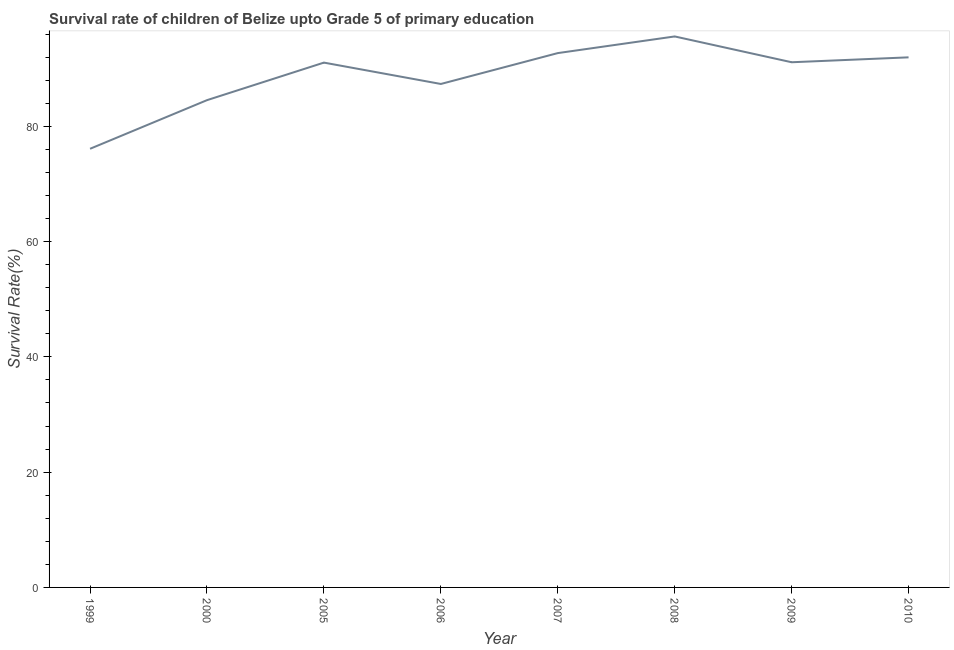What is the survival rate in 2000?
Provide a short and direct response. 84.53. Across all years, what is the maximum survival rate?
Offer a terse response. 95.58. Across all years, what is the minimum survival rate?
Your answer should be very brief. 76.09. In which year was the survival rate maximum?
Give a very brief answer. 2008. What is the sum of the survival rate?
Give a very brief answer. 710.34. What is the difference between the survival rate in 2000 and 2006?
Give a very brief answer. -2.81. What is the average survival rate per year?
Offer a terse response. 88.79. What is the median survival rate?
Your response must be concise. 91.07. What is the ratio of the survival rate in 1999 to that in 2000?
Make the answer very short. 0.9. Is the difference between the survival rate in 1999 and 2000 greater than the difference between any two years?
Your answer should be compact. No. What is the difference between the highest and the second highest survival rate?
Your answer should be compact. 2.89. Is the sum of the survival rate in 2007 and 2010 greater than the maximum survival rate across all years?
Provide a short and direct response. Yes. What is the difference between the highest and the lowest survival rate?
Offer a very short reply. 19.49. In how many years, is the survival rate greater than the average survival rate taken over all years?
Keep it short and to the point. 5. Does the survival rate monotonically increase over the years?
Your answer should be very brief. No. What is the difference between two consecutive major ticks on the Y-axis?
Make the answer very short. 20. Does the graph contain any zero values?
Your answer should be compact. No. Does the graph contain grids?
Provide a short and direct response. No. What is the title of the graph?
Give a very brief answer. Survival rate of children of Belize upto Grade 5 of primary education. What is the label or title of the Y-axis?
Give a very brief answer. Survival Rate(%). What is the Survival Rate(%) of 1999?
Give a very brief answer. 76.09. What is the Survival Rate(%) of 2000?
Give a very brief answer. 84.53. What is the Survival Rate(%) of 2005?
Offer a terse response. 91.04. What is the Survival Rate(%) in 2006?
Your response must be concise. 87.34. What is the Survival Rate(%) in 2007?
Make the answer very short. 92.69. What is the Survival Rate(%) in 2008?
Keep it short and to the point. 95.58. What is the Survival Rate(%) of 2009?
Make the answer very short. 91.11. What is the Survival Rate(%) in 2010?
Offer a very short reply. 91.96. What is the difference between the Survival Rate(%) in 1999 and 2000?
Offer a terse response. -8.43. What is the difference between the Survival Rate(%) in 1999 and 2005?
Your response must be concise. -14.95. What is the difference between the Survival Rate(%) in 1999 and 2006?
Provide a short and direct response. -11.24. What is the difference between the Survival Rate(%) in 1999 and 2007?
Ensure brevity in your answer.  -16.6. What is the difference between the Survival Rate(%) in 1999 and 2008?
Offer a very short reply. -19.49. What is the difference between the Survival Rate(%) in 1999 and 2009?
Keep it short and to the point. -15.01. What is the difference between the Survival Rate(%) in 1999 and 2010?
Offer a very short reply. -15.86. What is the difference between the Survival Rate(%) in 2000 and 2005?
Give a very brief answer. -6.51. What is the difference between the Survival Rate(%) in 2000 and 2006?
Your response must be concise. -2.81. What is the difference between the Survival Rate(%) in 2000 and 2007?
Make the answer very short. -8.16. What is the difference between the Survival Rate(%) in 2000 and 2008?
Give a very brief answer. -11.05. What is the difference between the Survival Rate(%) in 2000 and 2009?
Provide a succinct answer. -6.58. What is the difference between the Survival Rate(%) in 2000 and 2010?
Your answer should be very brief. -7.43. What is the difference between the Survival Rate(%) in 2005 and 2006?
Your answer should be compact. 3.7. What is the difference between the Survival Rate(%) in 2005 and 2007?
Your answer should be compact. -1.65. What is the difference between the Survival Rate(%) in 2005 and 2008?
Your response must be concise. -4.54. What is the difference between the Survival Rate(%) in 2005 and 2009?
Make the answer very short. -0.06. What is the difference between the Survival Rate(%) in 2005 and 2010?
Keep it short and to the point. -0.91. What is the difference between the Survival Rate(%) in 2006 and 2007?
Offer a terse response. -5.36. What is the difference between the Survival Rate(%) in 2006 and 2008?
Offer a very short reply. -8.24. What is the difference between the Survival Rate(%) in 2006 and 2009?
Give a very brief answer. -3.77. What is the difference between the Survival Rate(%) in 2006 and 2010?
Your answer should be very brief. -4.62. What is the difference between the Survival Rate(%) in 2007 and 2008?
Your response must be concise. -2.89. What is the difference between the Survival Rate(%) in 2007 and 2009?
Provide a succinct answer. 1.59. What is the difference between the Survival Rate(%) in 2007 and 2010?
Ensure brevity in your answer.  0.74. What is the difference between the Survival Rate(%) in 2008 and 2009?
Provide a succinct answer. 4.48. What is the difference between the Survival Rate(%) in 2008 and 2010?
Offer a very short reply. 3.63. What is the difference between the Survival Rate(%) in 2009 and 2010?
Provide a short and direct response. -0.85. What is the ratio of the Survival Rate(%) in 1999 to that in 2005?
Offer a terse response. 0.84. What is the ratio of the Survival Rate(%) in 1999 to that in 2006?
Give a very brief answer. 0.87. What is the ratio of the Survival Rate(%) in 1999 to that in 2007?
Give a very brief answer. 0.82. What is the ratio of the Survival Rate(%) in 1999 to that in 2008?
Make the answer very short. 0.8. What is the ratio of the Survival Rate(%) in 1999 to that in 2009?
Make the answer very short. 0.83. What is the ratio of the Survival Rate(%) in 1999 to that in 2010?
Provide a short and direct response. 0.83. What is the ratio of the Survival Rate(%) in 2000 to that in 2005?
Ensure brevity in your answer.  0.93. What is the ratio of the Survival Rate(%) in 2000 to that in 2007?
Offer a very short reply. 0.91. What is the ratio of the Survival Rate(%) in 2000 to that in 2008?
Your answer should be very brief. 0.88. What is the ratio of the Survival Rate(%) in 2000 to that in 2009?
Provide a succinct answer. 0.93. What is the ratio of the Survival Rate(%) in 2000 to that in 2010?
Your answer should be very brief. 0.92. What is the ratio of the Survival Rate(%) in 2005 to that in 2006?
Keep it short and to the point. 1.04. What is the ratio of the Survival Rate(%) in 2005 to that in 2010?
Keep it short and to the point. 0.99. What is the ratio of the Survival Rate(%) in 2006 to that in 2007?
Offer a very short reply. 0.94. What is the ratio of the Survival Rate(%) in 2006 to that in 2008?
Your answer should be compact. 0.91. What is the ratio of the Survival Rate(%) in 2006 to that in 2009?
Your response must be concise. 0.96. What is the ratio of the Survival Rate(%) in 2006 to that in 2010?
Provide a short and direct response. 0.95. What is the ratio of the Survival Rate(%) in 2008 to that in 2009?
Keep it short and to the point. 1.05. What is the ratio of the Survival Rate(%) in 2008 to that in 2010?
Provide a short and direct response. 1.04. 